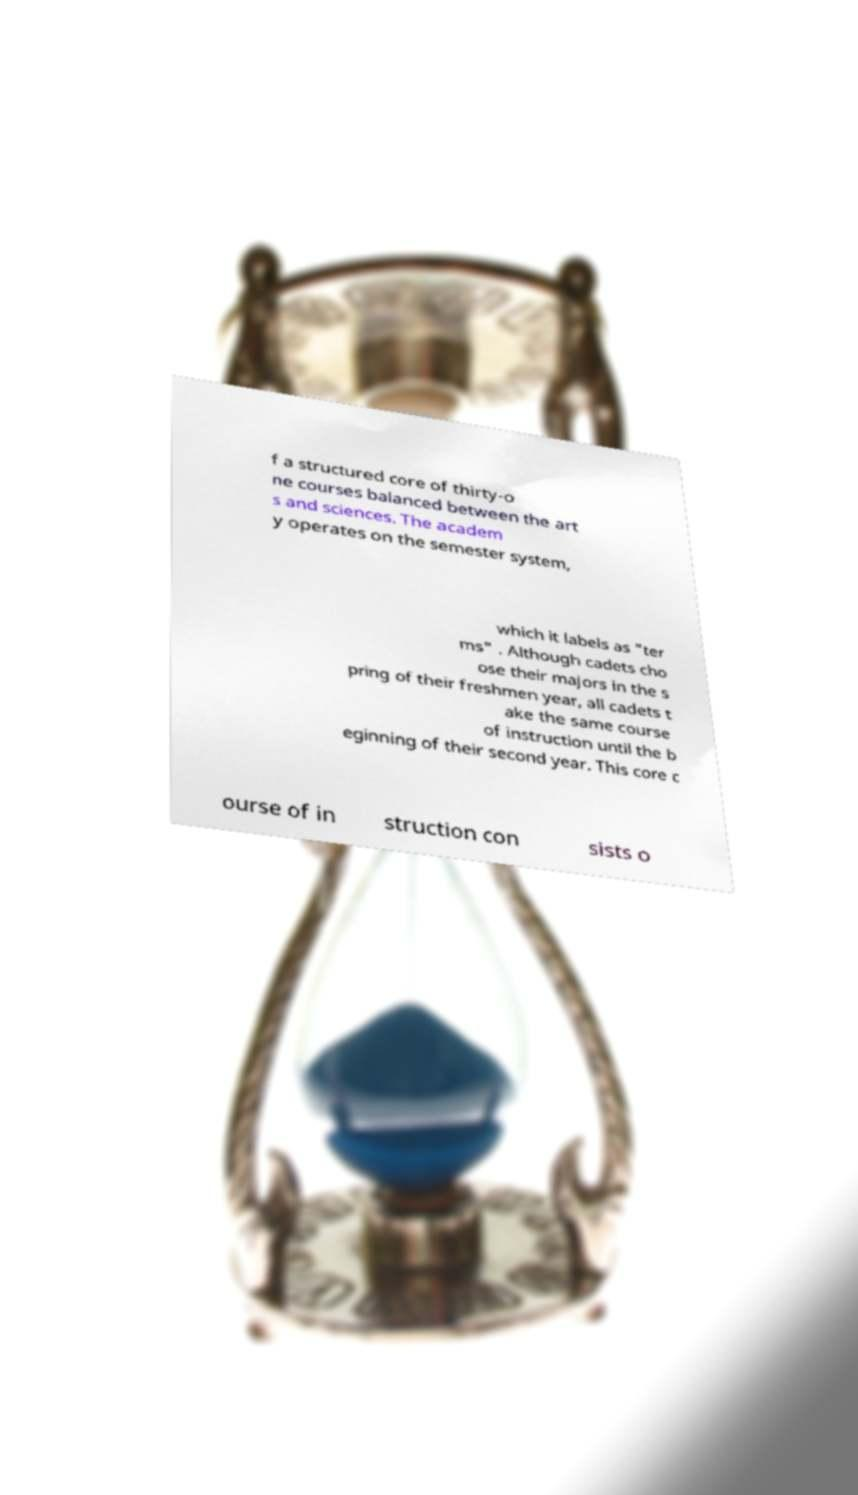Can you accurately transcribe the text from the provided image for me? f a structured core of thirty-o ne courses balanced between the art s and sciences. The academ y operates on the semester system, which it labels as "ter ms" . Although cadets cho ose their majors in the s pring of their freshmen year, all cadets t ake the same course of instruction until the b eginning of their second year. This core c ourse of in struction con sists o 